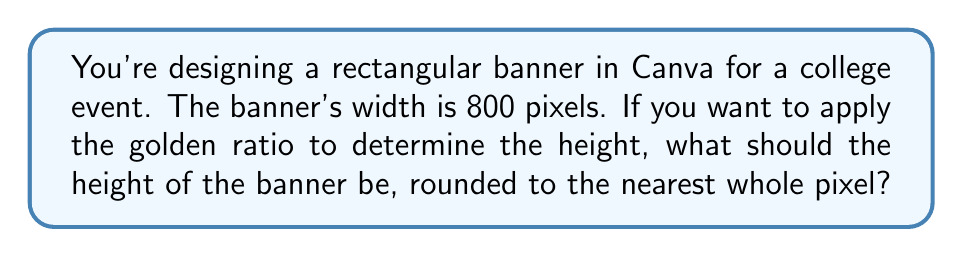Help me with this question. To solve this problem, we need to understand and apply the golden ratio concept:

1. The golden ratio, denoted by φ (phi), is approximately equal to 1.618033988749895.

2. In a rectangle with the golden ratio, the ratio of the longer side to the shorter side is equal to φ.

3. Given:
   - Width of the banner = 800 pixels
   - We need to find the height

4. Let's set up the equation:
   $\frac{\text{longer side}}{\text{shorter side}} = φ$

5. In this case, the width is longer, so:
   $\frac{800}{\text{height}} = φ$

6. Solve for height:
   $\text{height} = \frac{800}{φ}$

7. Substitute the value of φ:
   $\text{height} = \frac{800}{1.618033988749895}$

8. Calculate:
   $\text{height} ≈ 494.427190999916$ pixels

9. Rounding to the nearest whole pixel:
   $\text{height} = 494$ pixels

Therefore, to maintain the golden ratio, the height of the banner should be 494 pixels.

To verify:
$\frac{800}{494} ≈ 1.619433198380567$, which is very close to φ (1.618033988749895).
Answer: 494 pixels 